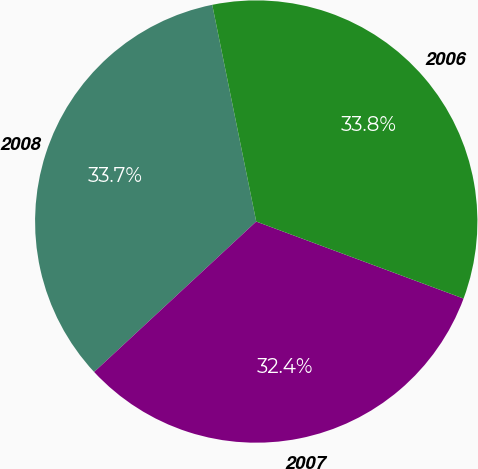<chart> <loc_0><loc_0><loc_500><loc_500><pie_chart><fcel>2008<fcel>2007<fcel>2006<nl><fcel>33.72%<fcel>32.43%<fcel>33.85%<nl></chart> 